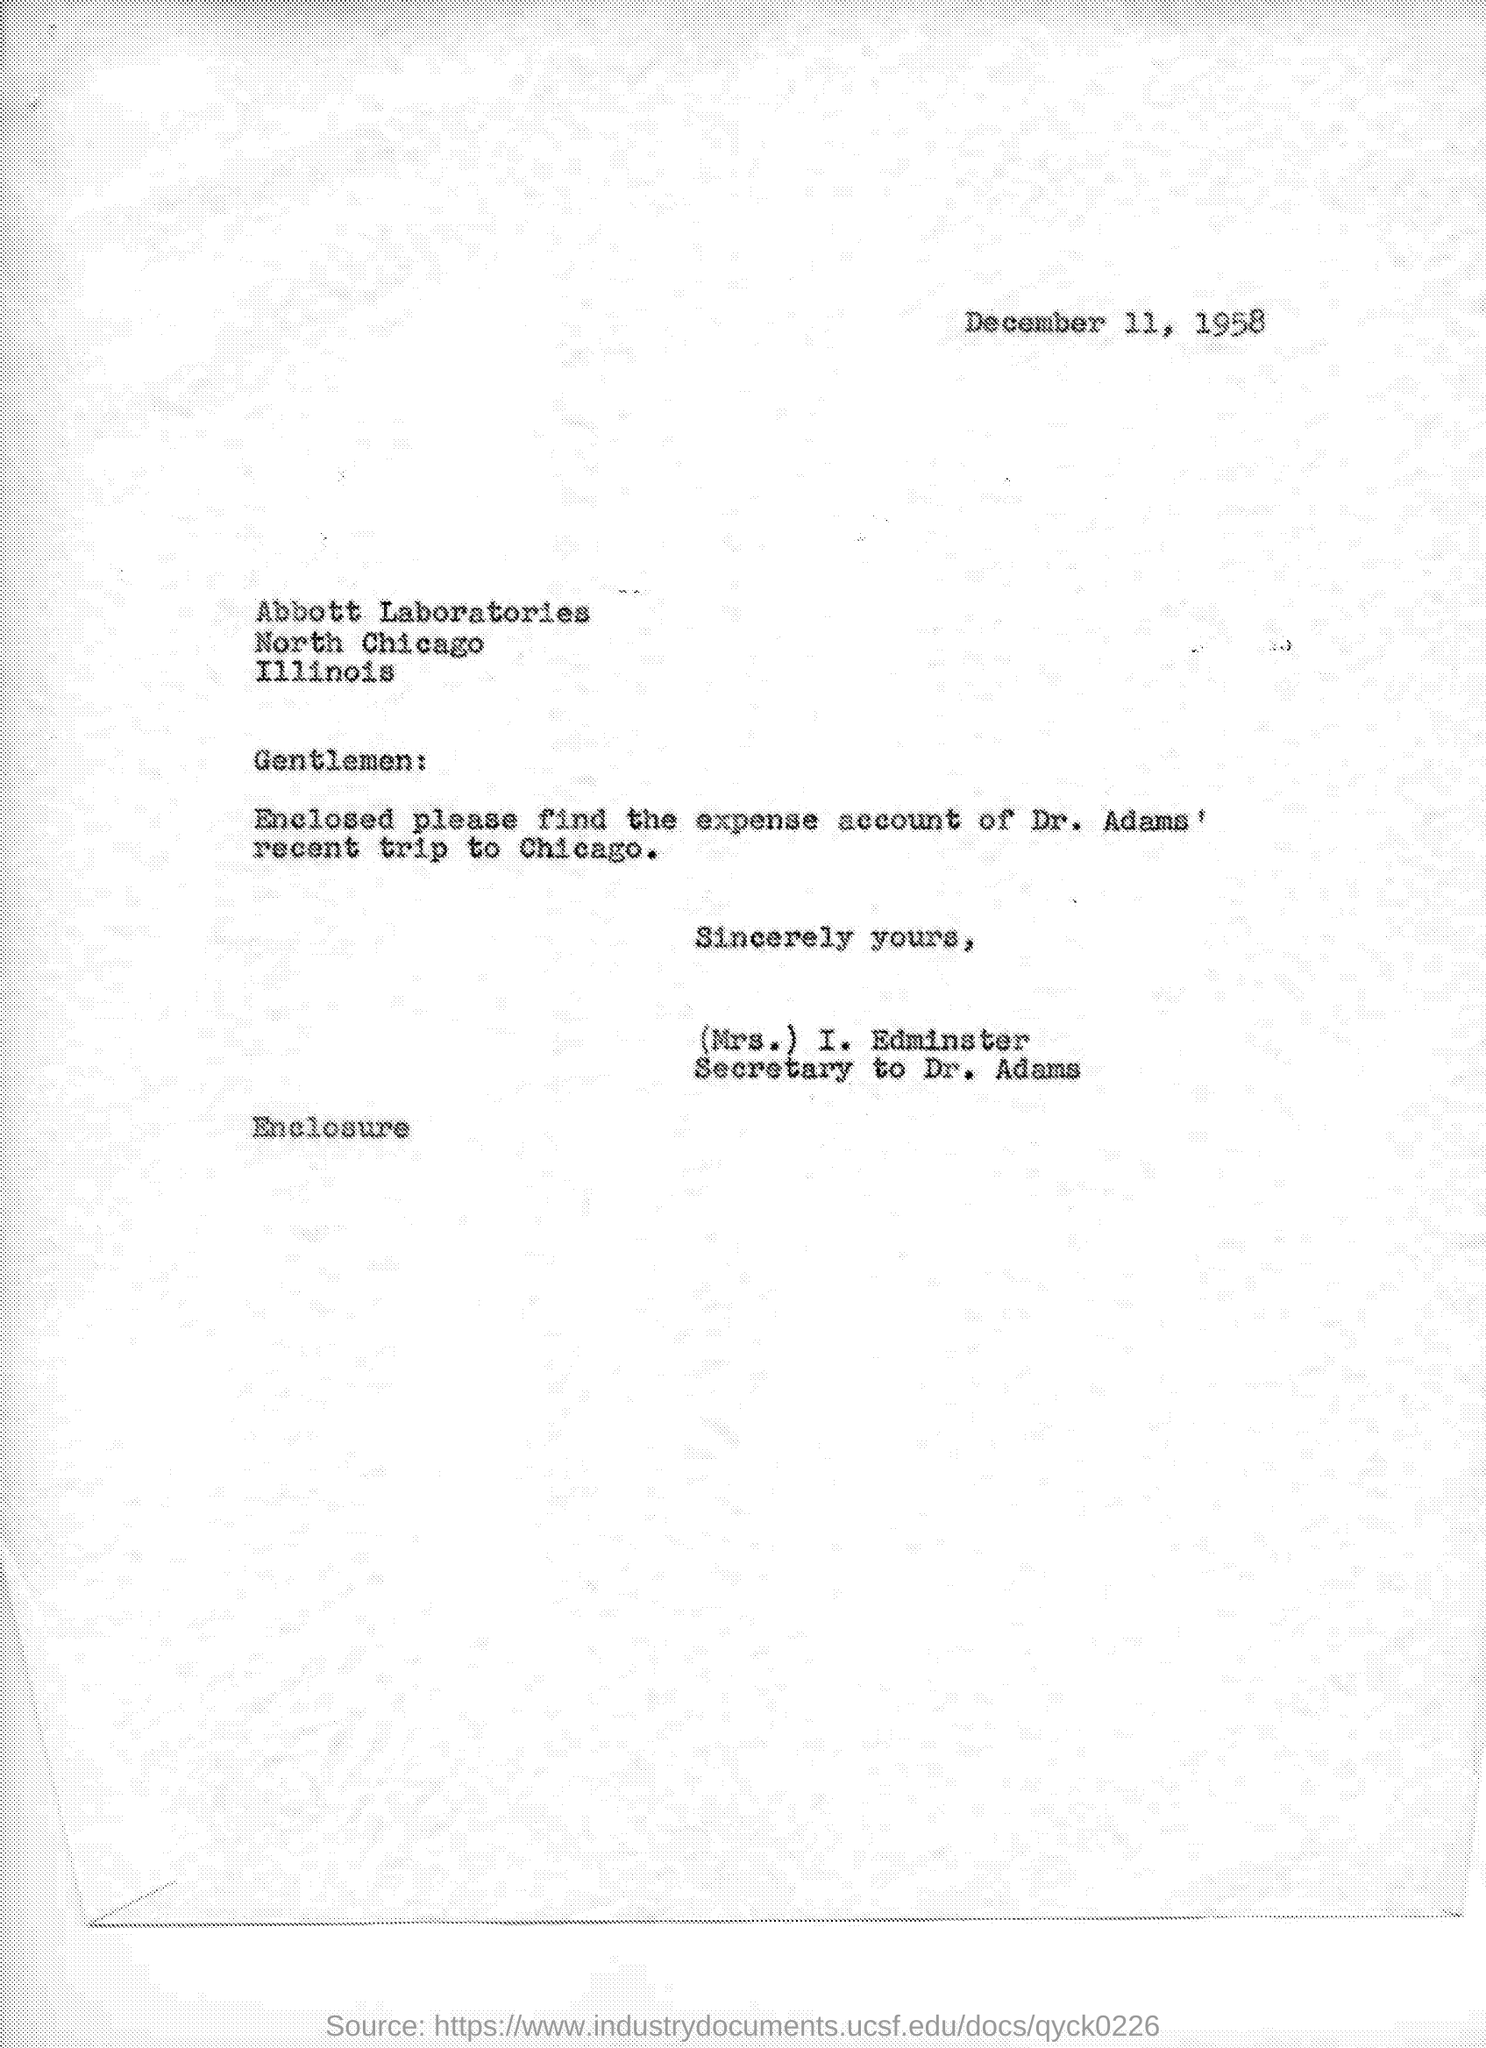What is the Date?
Make the answer very short. DECEMBER 11, 1958. Who is this letter from?
Keep it short and to the point. (Mrs.) I. Edminster. Whose expense account of recent trip to Chicago is enclosed?
Offer a terse response. DR. ADAMS. 